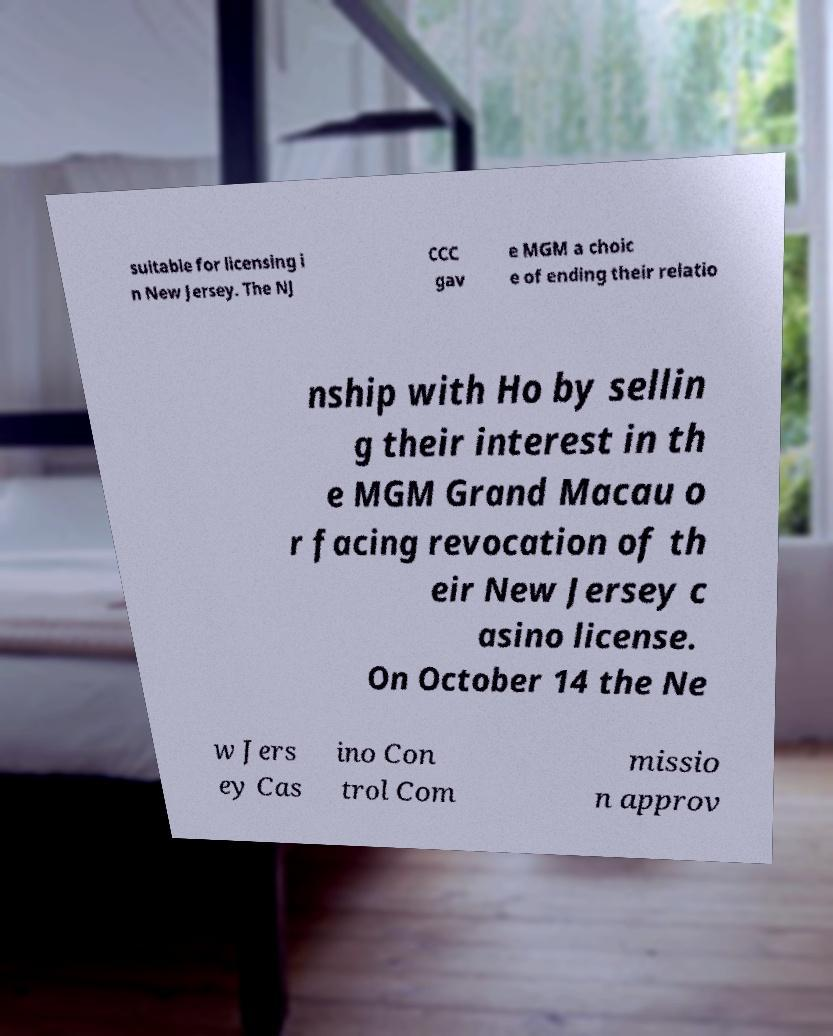What messages or text are displayed in this image? I need them in a readable, typed format. suitable for licensing i n New Jersey. The NJ CCC gav e MGM a choic e of ending their relatio nship with Ho by sellin g their interest in th e MGM Grand Macau o r facing revocation of th eir New Jersey c asino license. On October 14 the Ne w Jers ey Cas ino Con trol Com missio n approv 